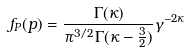<formula> <loc_0><loc_0><loc_500><loc_500>f _ { P } ( p ) = \frac { \Gamma ( \kappa ) } { \pi ^ { 3 / 2 } \Gamma ( \kappa - \frac { 3 } { 2 } ) } \gamma ^ { - 2 \kappa }</formula> 